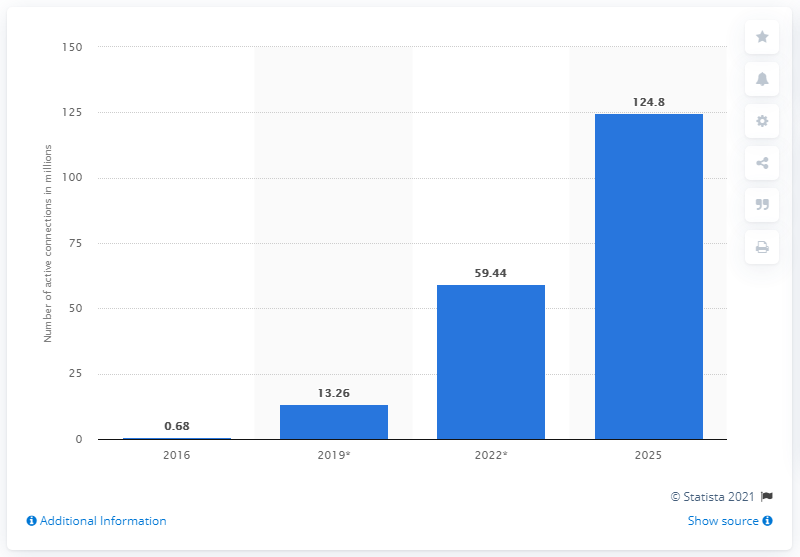Mention a couple of crucial points in this snapshot. According to forecasts, the number of active Internet of Things (IoT) connections in the tracking sector is expected to reach 124.8 million by 2025. 